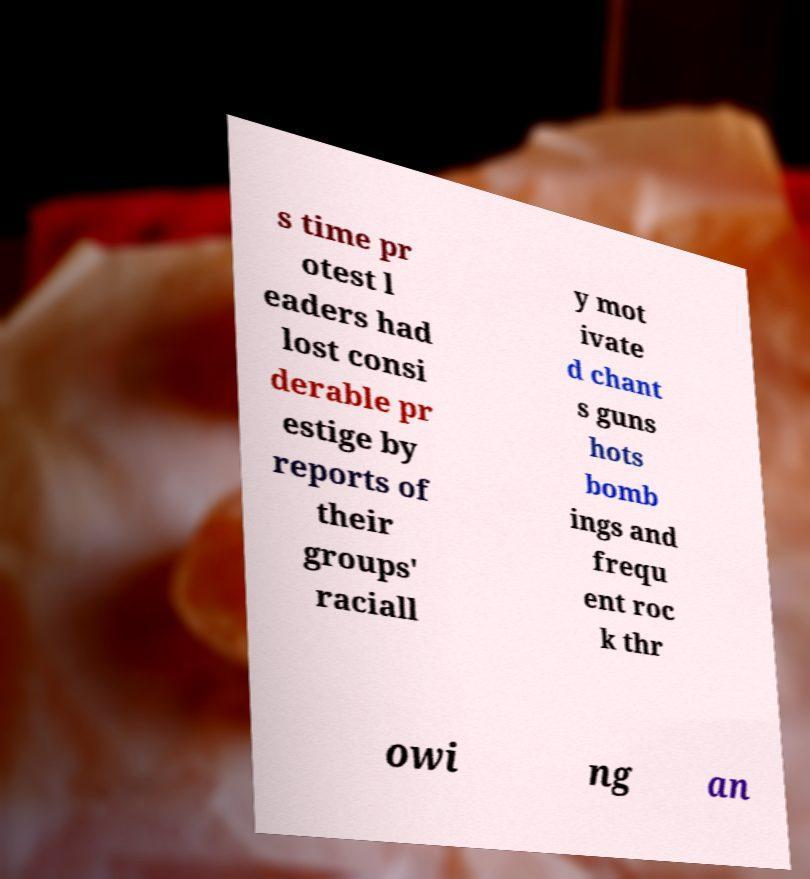Please identify and transcribe the text found in this image. s time pr otest l eaders had lost consi derable pr estige by reports of their groups' raciall y mot ivate d chant s guns hots bomb ings and frequ ent roc k thr owi ng an 